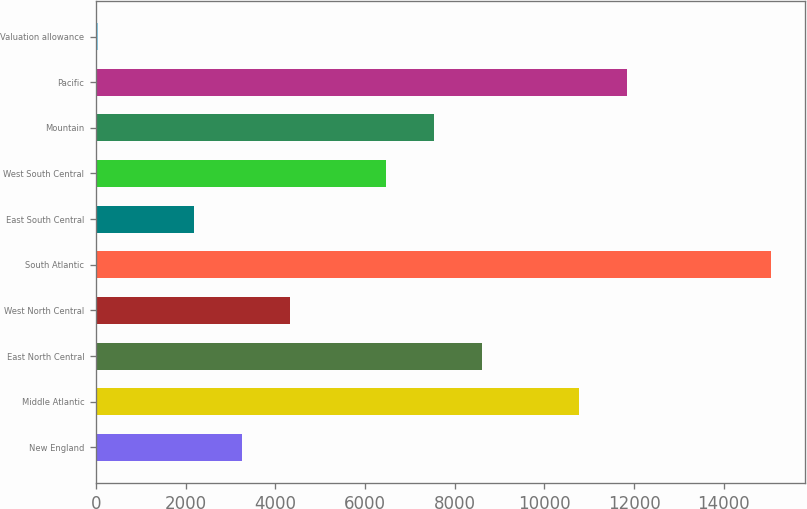<chart> <loc_0><loc_0><loc_500><loc_500><bar_chart><fcel>New England<fcel>Middle Atlantic<fcel>East North Central<fcel>West North Central<fcel>South Atlantic<fcel>East South Central<fcel>West South Central<fcel>Mountain<fcel>Pacific<fcel>Valuation allowance<nl><fcel>3259.01<fcel>10763.5<fcel>8619.36<fcel>4331.08<fcel>15051.8<fcel>2186.94<fcel>6475.22<fcel>7547.29<fcel>11835.6<fcel>42.8<nl></chart> 